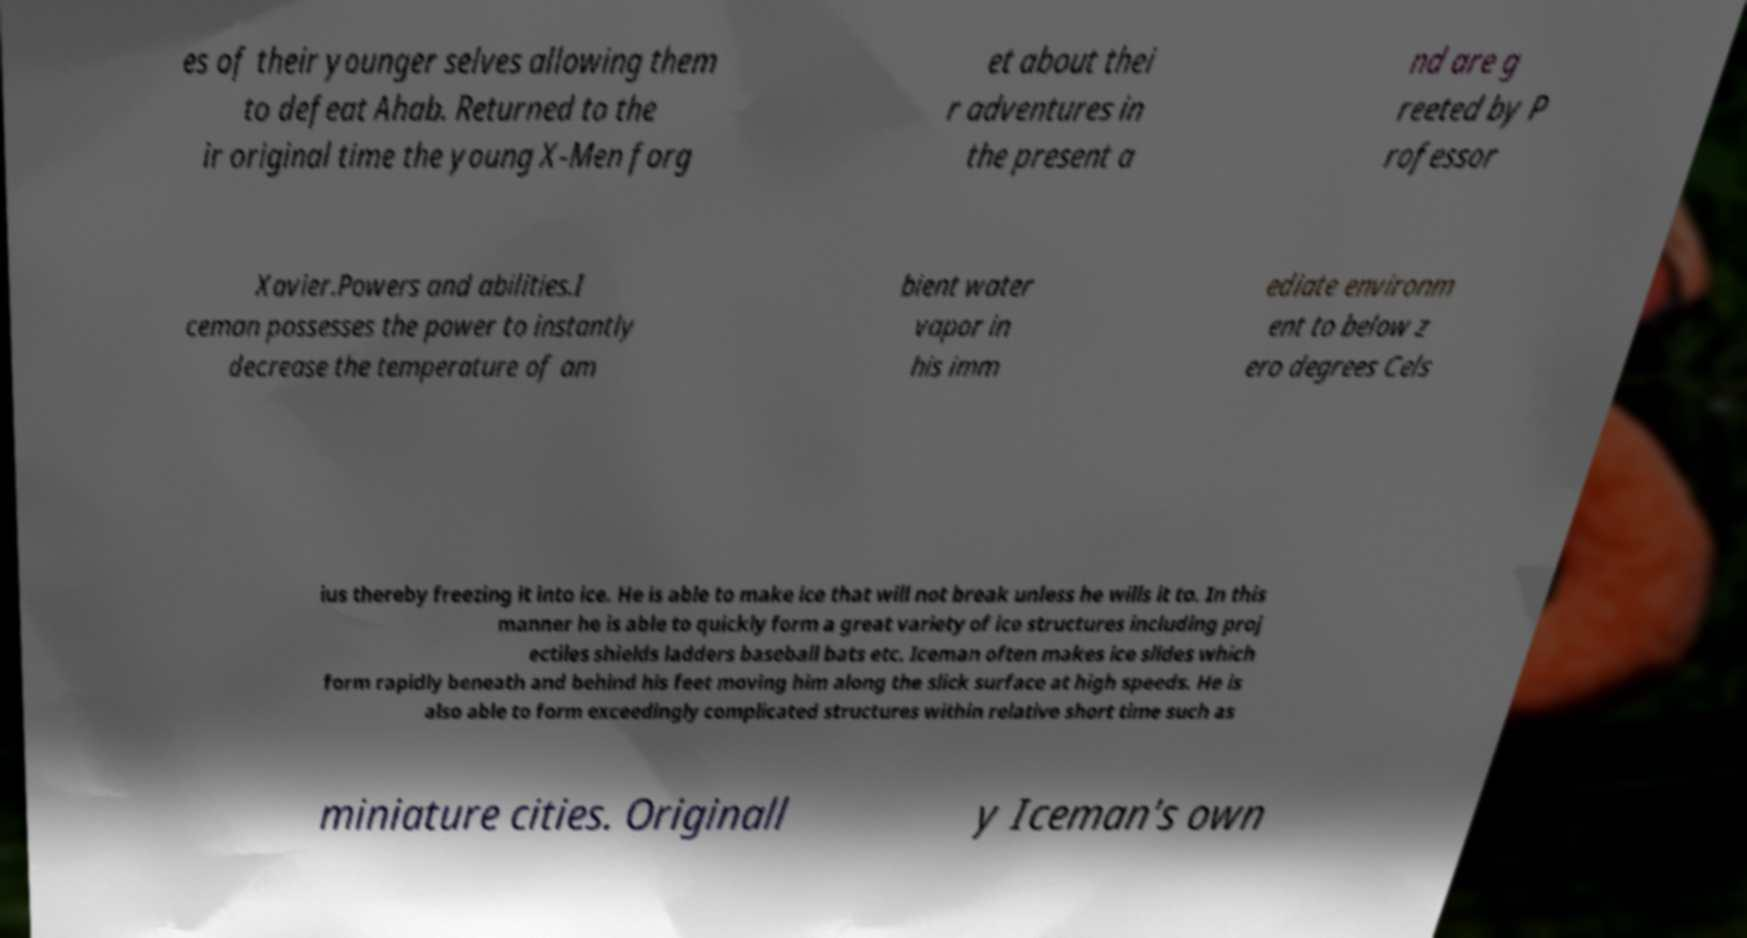Can you accurately transcribe the text from the provided image for me? es of their younger selves allowing them to defeat Ahab. Returned to the ir original time the young X-Men forg et about thei r adventures in the present a nd are g reeted by P rofessor Xavier.Powers and abilities.I ceman possesses the power to instantly decrease the temperature of am bient water vapor in his imm ediate environm ent to below z ero degrees Cels ius thereby freezing it into ice. He is able to make ice that will not break unless he wills it to. In this manner he is able to quickly form a great variety of ice structures including proj ectiles shields ladders baseball bats etc. Iceman often makes ice slides which form rapidly beneath and behind his feet moving him along the slick surface at high speeds. He is also able to form exceedingly complicated structures within relative short time such as miniature cities. Originall y Iceman's own 